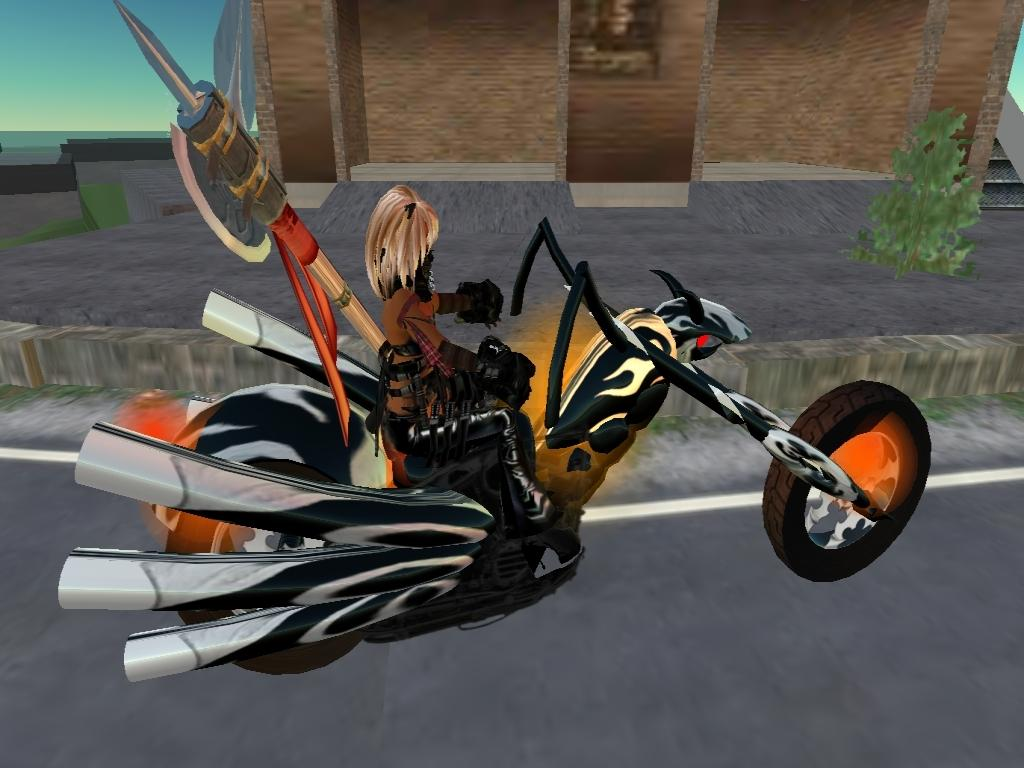Who or what is present in the image? There is a person in the image. What is the person doing or where are they located? The person is on a vehicle. What can be seen in the background of the image? There is a building in the background of the image. Are there any other objects or living organisms in the image? Yes, there is a plant in the image. What type of pleasure can be seen on the person's face in the image? There is no indication of pleasure or any facial expression on the person's face in the image. 